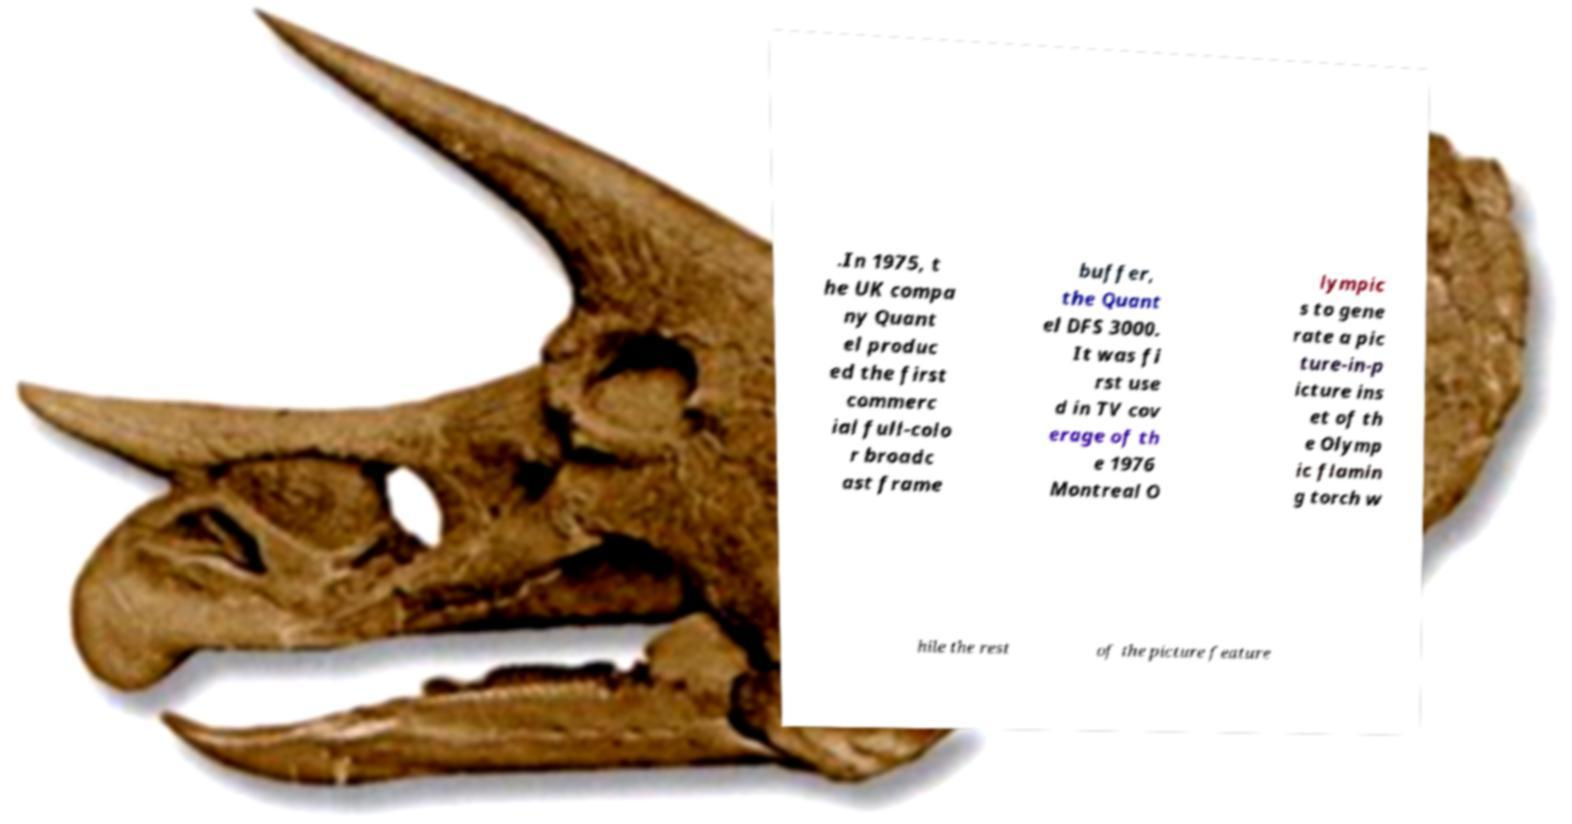Can you read and provide the text displayed in the image?This photo seems to have some interesting text. Can you extract and type it out for me? .In 1975, t he UK compa ny Quant el produc ed the first commerc ial full-colo r broadc ast frame buffer, the Quant el DFS 3000. It was fi rst use d in TV cov erage of th e 1976 Montreal O lympic s to gene rate a pic ture-in-p icture ins et of th e Olymp ic flamin g torch w hile the rest of the picture feature 